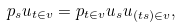Convert formula to latex. <formula><loc_0><loc_0><loc_500><loc_500>p _ { s } u _ { t \in v } = p _ { t \in v } u _ { s } u _ { ( t s ) \in v } ,</formula> 